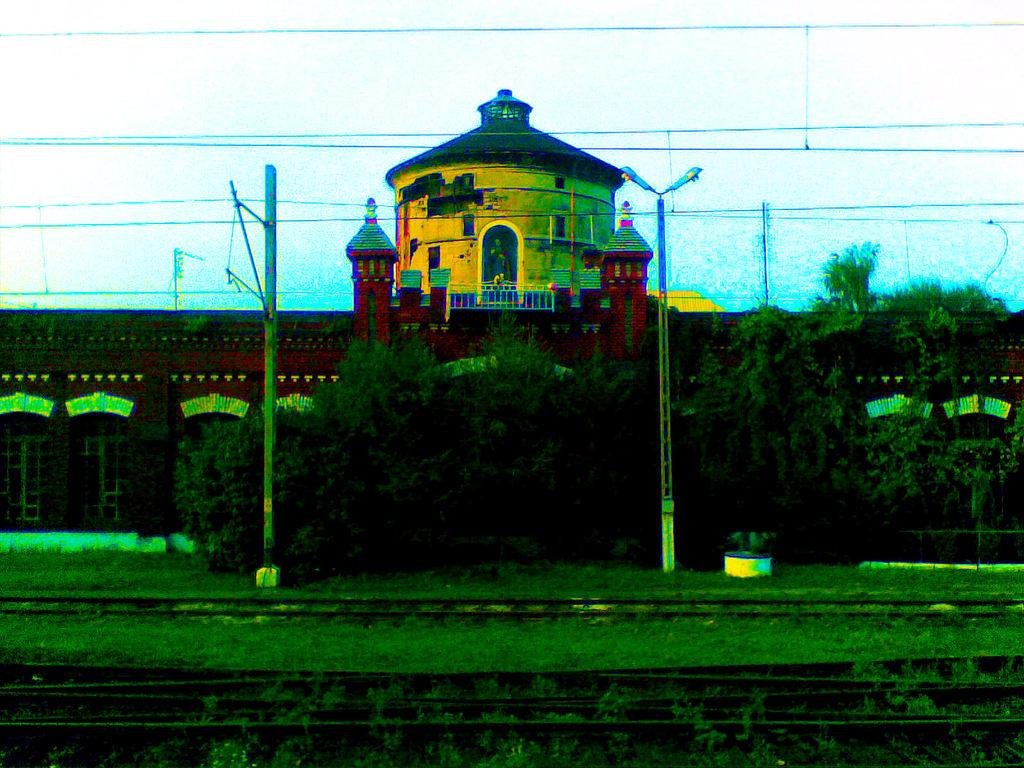What type of transportation infrastructure is visible in the image? There are railway tracks in the image. What can be seen on the ground in the image? There is grass on the ground in the image. What structures are present in the image? There are poles and a building visible in the image. What type of lighting is present in the image? There are street lights in the image. What is located on top of the poles in the image? There are wires on top in the image. What can be seen in the background of the image? There is a tree and a building in the background of the image. What type of soup is being served in the image? There is no soup present in the image; it features railway tracks, grass, poles, street lights, wires, a tree, and a building. 